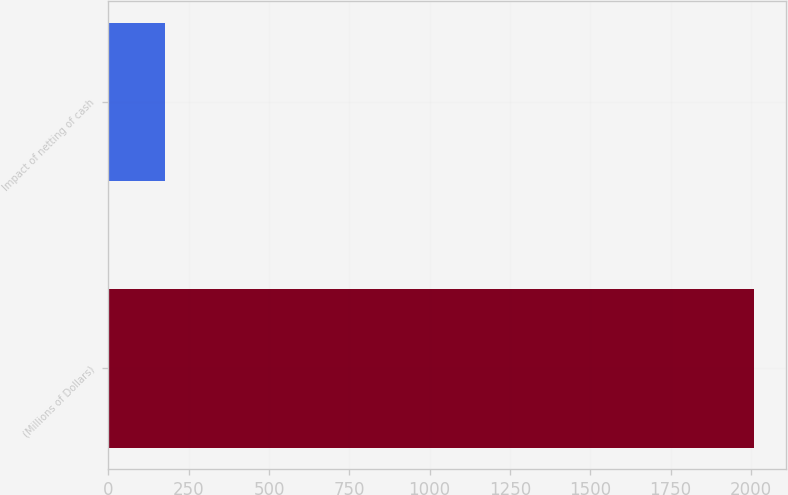Convert chart. <chart><loc_0><loc_0><loc_500><loc_500><bar_chart><fcel>(Millions of Dollars)<fcel>Impact of netting of cash<nl><fcel>2010<fcel>176<nl></chart> 